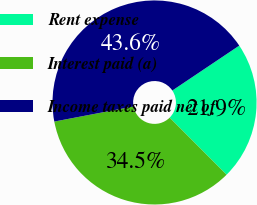Convert chart. <chart><loc_0><loc_0><loc_500><loc_500><pie_chart><fcel>Rent expense<fcel>Interest paid (a)<fcel>Income taxes paid net of<nl><fcel>21.93%<fcel>34.48%<fcel>43.59%<nl></chart> 